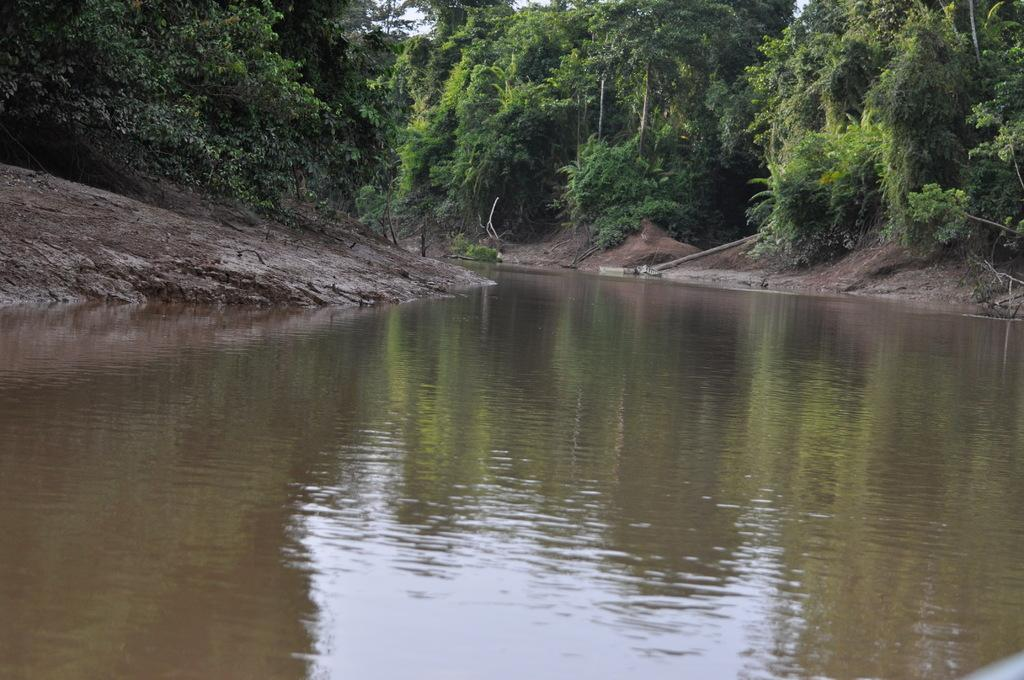What is present at the bottom of the image? There is water at the bottom of the image. What can be seen on both sides of the image? There are trees on both sides of the image. How many dimes are visible in the image? There are no dimes present in the image. Is the water in the image hot or cold? The provided facts do not mention the temperature of the water, so it cannot be determined from the image. 